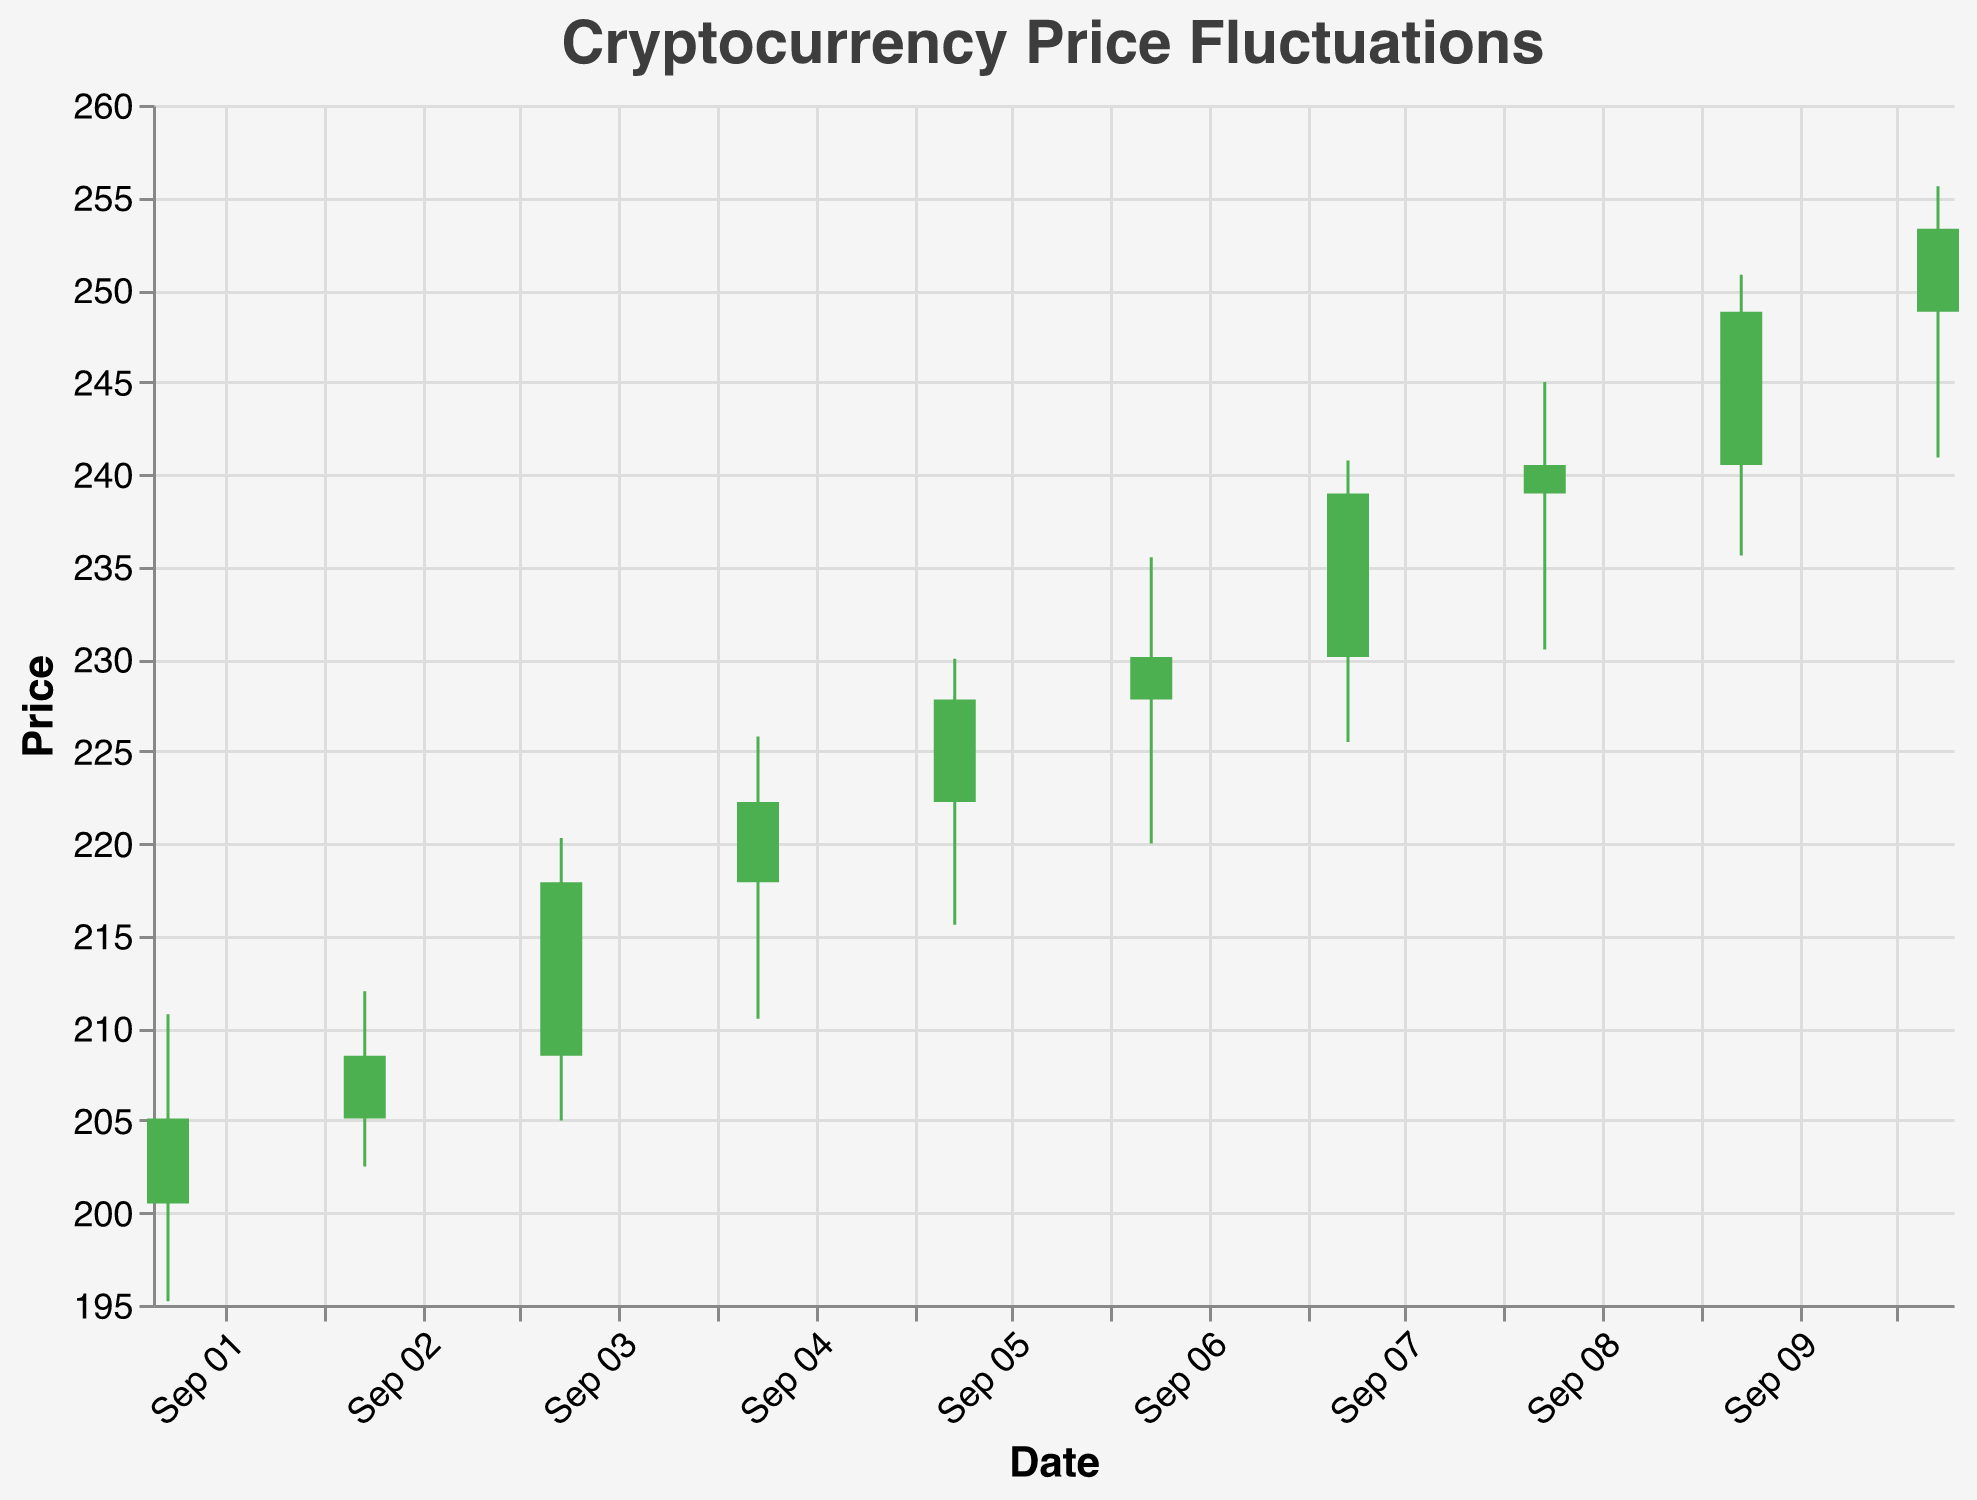What is the highest price recorded during the given period? The highest price recorded can be found by looking at the maximum value on the y-axis of the "High" points. Here, the highest price is on September 9, where the price reached 250.80.
Answer: 250.80 How does the closing price on September 10 compare to the opening price on the same day? The closing price on September 10 is 253.30 and the opening price on the same day is 248.80. Thus, the closing price is higher than the opening price.
Answer: The closing price is higher Which date had the maximum price fluctuation (difference between 'High' and 'Low')? To find the date with the maximum price fluctuation, subtract the 'Low' from the 'High' for each date and compare. The maximum fluctuation is on September 9, with High of 250.80 and Low of 235.60, resulting in a fluctuation of 15.20.
Answer: September 9 How does the volume correlate to the days with a significant price increase? Days with a significant price increase often have a correlation with higher trading volumes. For instance, September 7 shows a notable increase in price (from 230.10 to 238.95) and corresponds with one of the higher volume days (3,600,000).
Answer: Higher volume often accompanies price increases What was the price trend from September 1 to September 10 based on the closing prices? Observing the closing prices from September 1 to September 10: the prices move consistently upward with minor dips. Starting at 205.10 on September 1 and ending at 253.30 on September 10.
Answer: Upward trend On which date did the closing price experience the largest single-day increase from the previous day's closing price? The largest single-day increase can be found by calculating the difference between the closing prices of consecutive days. The biggest increase is from September 8 to September 9, where the closing price went from 240.50 to 248.80, an increase of 8.30.
Answer: September 9 What color represents days when the closing price is higher than the opening price? In the candlestick chart, the days when the closing price is higher than the opening price are represented by green bars.
Answer: Green Which day had the highest trading volume and what was the closing price on that day? By looking at the volume figures, the highest trading volume is on September 9, with 3,700,000 units. The closing price on that day is 248.80.
Answer: September 9, 248.80 